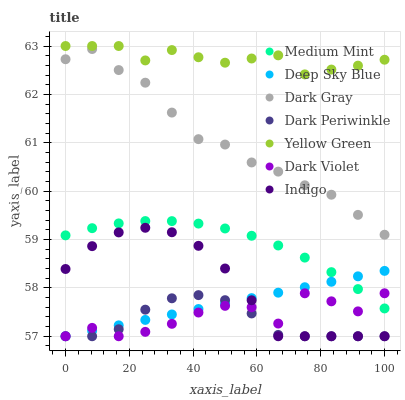Does Dark Periwinkle have the minimum area under the curve?
Answer yes or no. Yes. Does Yellow Green have the maximum area under the curve?
Answer yes or no. Yes. Does Indigo have the minimum area under the curve?
Answer yes or no. No. Does Indigo have the maximum area under the curve?
Answer yes or no. No. Is Deep Sky Blue the smoothest?
Answer yes or no. Yes. Is Dark Violet the roughest?
Answer yes or no. Yes. Is Indigo the smoothest?
Answer yes or no. No. Is Indigo the roughest?
Answer yes or no. No. Does Indigo have the lowest value?
Answer yes or no. Yes. Does Yellow Green have the lowest value?
Answer yes or no. No. Does Yellow Green have the highest value?
Answer yes or no. Yes. Does Indigo have the highest value?
Answer yes or no. No. Is Dark Violet less than Dark Gray?
Answer yes or no. Yes. Is Dark Gray greater than Medium Mint?
Answer yes or no. Yes. Does Deep Sky Blue intersect Indigo?
Answer yes or no. Yes. Is Deep Sky Blue less than Indigo?
Answer yes or no. No. Is Deep Sky Blue greater than Indigo?
Answer yes or no. No. Does Dark Violet intersect Dark Gray?
Answer yes or no. No. 